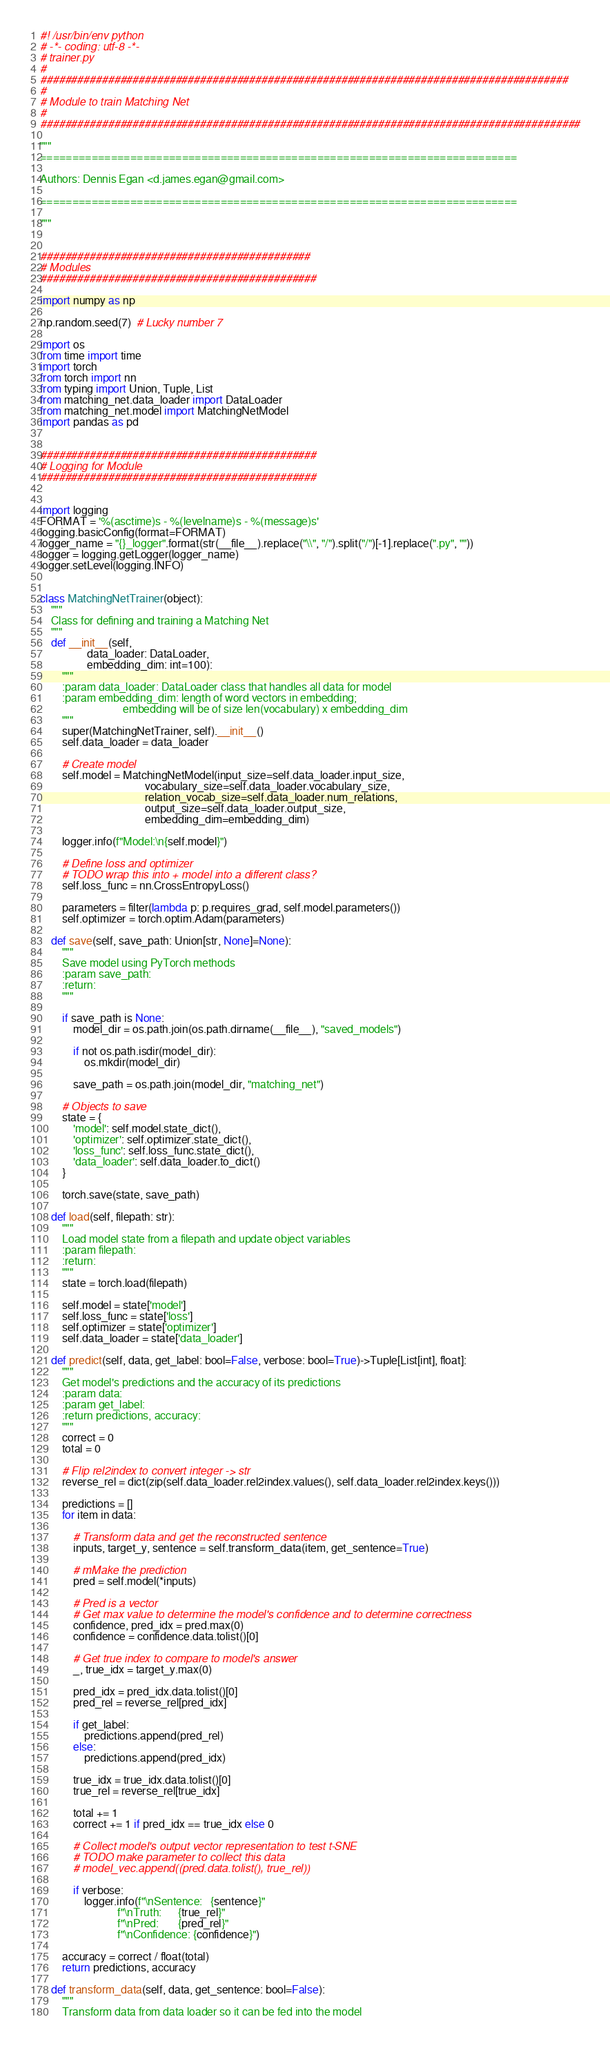<code> <loc_0><loc_0><loc_500><loc_500><_Python_>#! /usr/bin/env python
# -*- coding: utf-8 -*-
# trainer.py
#
######################################################################################
#
# Module to train Matching Net
#
########################################################################################

"""
==========================================================================

Authors: Dennis Egan <d.james.egan@gmail.com>

==========================================================================

"""


############################################
# Modules
#############################################

import numpy as np

np.random.seed(7)  # Lucky number 7

import os
from time import time
import torch
from torch import nn
from typing import Union, Tuple, List
from matching_net.data_loader import DataLoader
from matching_net.model import MatchingNetModel
import pandas as pd


#############################################
# Logging for Module
#############################################


import logging
FORMAT = '%(asctime)s - %(levelname)s - %(message)s'
logging.basicConfig(format=FORMAT)
logger_name = "{}_logger".format(str(__file__).replace("\\", "/").split("/")[-1].replace(".py", ""))
logger = logging.getLogger(logger_name)
logger.setLevel(logging.INFO)


class MatchingNetTrainer(object):
    """
    Class for defining and training a Matching Net
    """
    def __init__(self,
                 data_loader: DataLoader,
                 embedding_dim: int=100):
        """
        :param data_loader: DataLoader class that handles all data for model
        :param embedding_dim: length of word vectors in embedding;
                              embedding will be of size len(vocabulary) x embedding_dim
        """
        super(MatchingNetTrainer, self).__init__()
        self.data_loader = data_loader

        # Create model
        self.model = MatchingNetModel(input_size=self.data_loader.input_size,
                                      vocabulary_size=self.data_loader.vocabulary_size,
                                      relation_vocab_size=self.data_loader.num_relations,
                                      output_size=self.data_loader.output_size,
                                      embedding_dim=embedding_dim)

        logger.info(f"Model:\n{self.model}")

        # Define loss and optimizer
        # TODO wrap this into + model into a different class?
        self.loss_func = nn.CrossEntropyLoss()

        parameters = filter(lambda p: p.requires_grad, self.model.parameters())
        self.optimizer = torch.optim.Adam(parameters)

    def save(self, save_path: Union[str, None]=None):
        """
        Save model using PyTorch methods
        :param save_path:
        :return:
        """

        if save_path is None:
            model_dir = os.path.join(os.path.dirname(__file__), "saved_models")

            if not os.path.isdir(model_dir):
                os.mkdir(model_dir)

            save_path = os.path.join(model_dir, "matching_net")

        # Objects to save
        state = {
            'model': self.model.state_dict(),
            'optimizer': self.optimizer.state_dict(),
            'loss_func': self.loss_func.state_dict(),
            'data_loader': self.data_loader.to_dict()
        }

        torch.save(state, save_path)

    def load(self, filepath: str):
        """
        Load model state from a filepath and update object variables
        :param filepath:
        :return:
        """
        state = torch.load(filepath)

        self.model = state['model']
        self.loss_func = state['loss']
        self.optimizer = state['optimizer']
        self.data_loader = state['data_loader']

    def predict(self, data, get_label: bool=False, verbose: bool=True)->Tuple[List[int], float]:
        """
        Get model's predictions and the accuracy of its predictions
        :param data:
        :param get_label:
        :return predictions, accuracy:
        """
        correct = 0
        total = 0

        # Flip rel2index to convert integer -> str
        reverse_rel = dict(zip(self.data_loader.rel2index.values(), self.data_loader.rel2index.keys()))

        predictions = []
        for item in data:

            # Transform data and get the reconstructed sentence
            inputs, target_y, sentence = self.transform_data(item, get_sentence=True)

            # mMake the prediction
            pred = self.model(*inputs)

            # Pred is a vector
            # Get max value to determine the model's confidence and to determine correctness
            confidence, pred_idx = pred.max(0)
            confidence = confidence.data.tolist()[0]

            # Get true index to compare to model's answer
            _, true_idx = target_y.max(0)

            pred_idx = pred_idx.data.tolist()[0]
            pred_rel = reverse_rel[pred_idx]

            if get_label:
                predictions.append(pred_rel)
            else:
                predictions.append(pred_idx)

            true_idx = true_idx.data.tolist()[0]
            true_rel = reverse_rel[true_idx]

            total += 1
            correct += 1 if pred_idx == true_idx else 0

            # Collect model's output vector representation to test t-SNE
            # TODO make parameter to collect this data
            # model_vec.append((pred.data.tolist(), true_rel))

            if verbose:
                logger.info(f"\nSentence:   {sentence}"
                            f"\nTruth:      {true_rel}"
                            f"\nPred:       {pred_rel}"
                            f"\nConfidence: {confidence}")

        accuracy = correct / float(total)
        return predictions, accuracy

    def transform_data(self, data, get_sentence: bool=False):
        """
        Transform data from data loader so it can be fed into the model</code> 